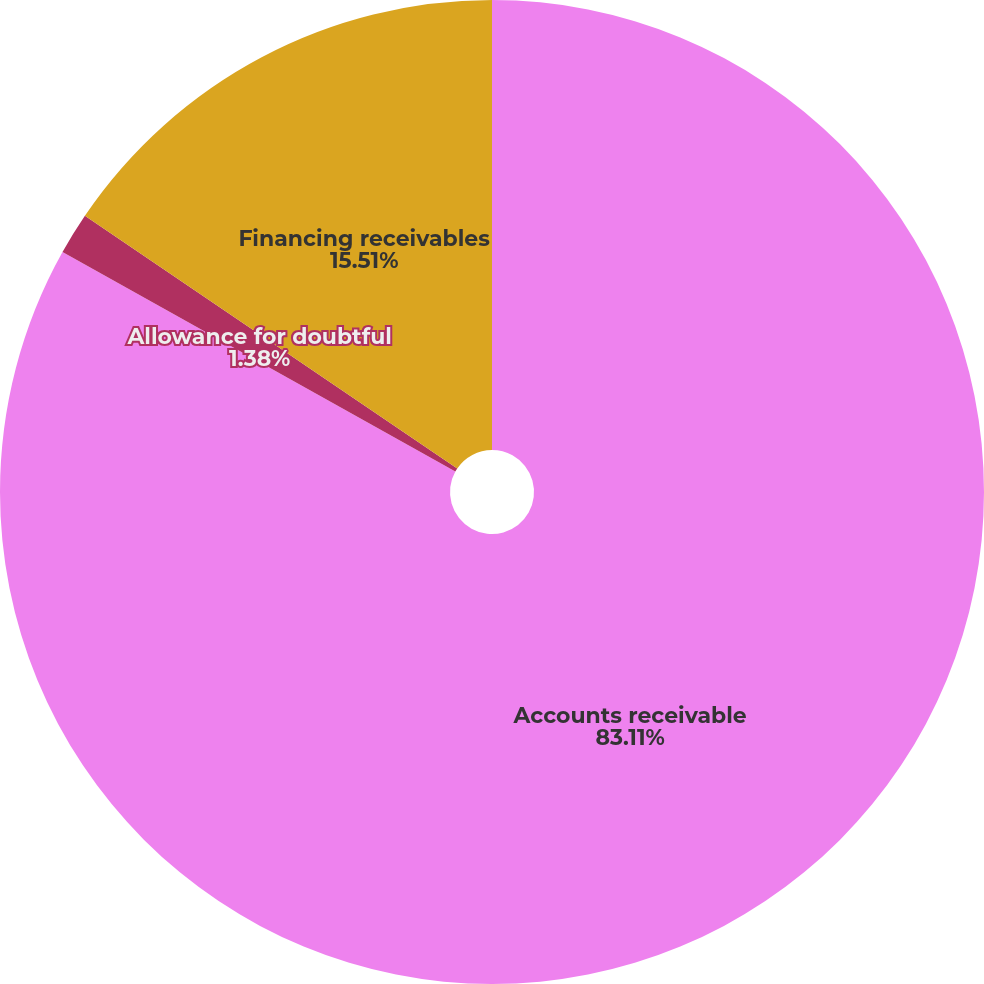<chart> <loc_0><loc_0><loc_500><loc_500><pie_chart><fcel>Accounts receivable<fcel>Allowance for doubtful<fcel>Financing receivables<nl><fcel>83.11%<fcel>1.38%<fcel>15.51%<nl></chart> 